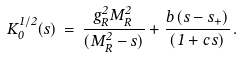<formula> <loc_0><loc_0><loc_500><loc_500>K _ { 0 } ^ { 1 / 2 } ( s ) \, = \, \frac { g _ { R } ^ { 2 } M _ { R } ^ { 2 } } { ( M _ { R } ^ { 2 } - s ) } + \frac { b \, ( s - s _ { + } ) } { ( 1 + c \, s ) } \, .</formula> 